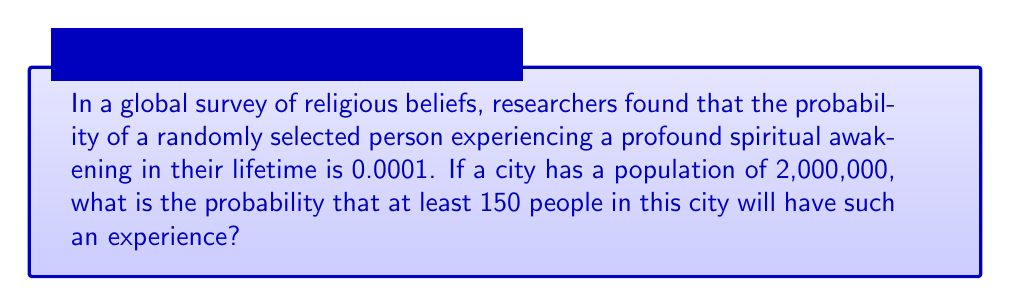Give your solution to this math problem. To solve this problem, we'll use the Poisson distribution, which is suitable for rare events in a large population.

1) First, calculate the expected number of people (λ) who will have this experience:
   $\lambda = np = 2,000,000 \times 0.0001 = 200$

2) We want the probability of 150 or more people having this experience, which is equivalent to 1 minus the probability of 149 or fewer people having it.

3) The Poisson probability mass function is:
   $P(X = k) = \frac{e^{-\lambda}\lambda^k}{k!}$

4) We need to sum this from 0 to 149:
   $P(X < 150) = \sum_{k=0}^{149} \frac{e^{-200}200^k}{k!}$

5) This sum is difficult to calculate by hand, so we typically use statistical software or tables. Using such a tool, we find:
   $P(X < 150) \approx 0.0002$

6) Therefore, the probability of 150 or more people having this experience is:
   $P(X \geq 150) = 1 - P(X < 150) = 1 - 0.0002 = 0.9998$

This high probability might seem counterintuitive for a "rare" event, but it demonstrates how even rare events can become likely in very large populations.
Answer: 0.9998 